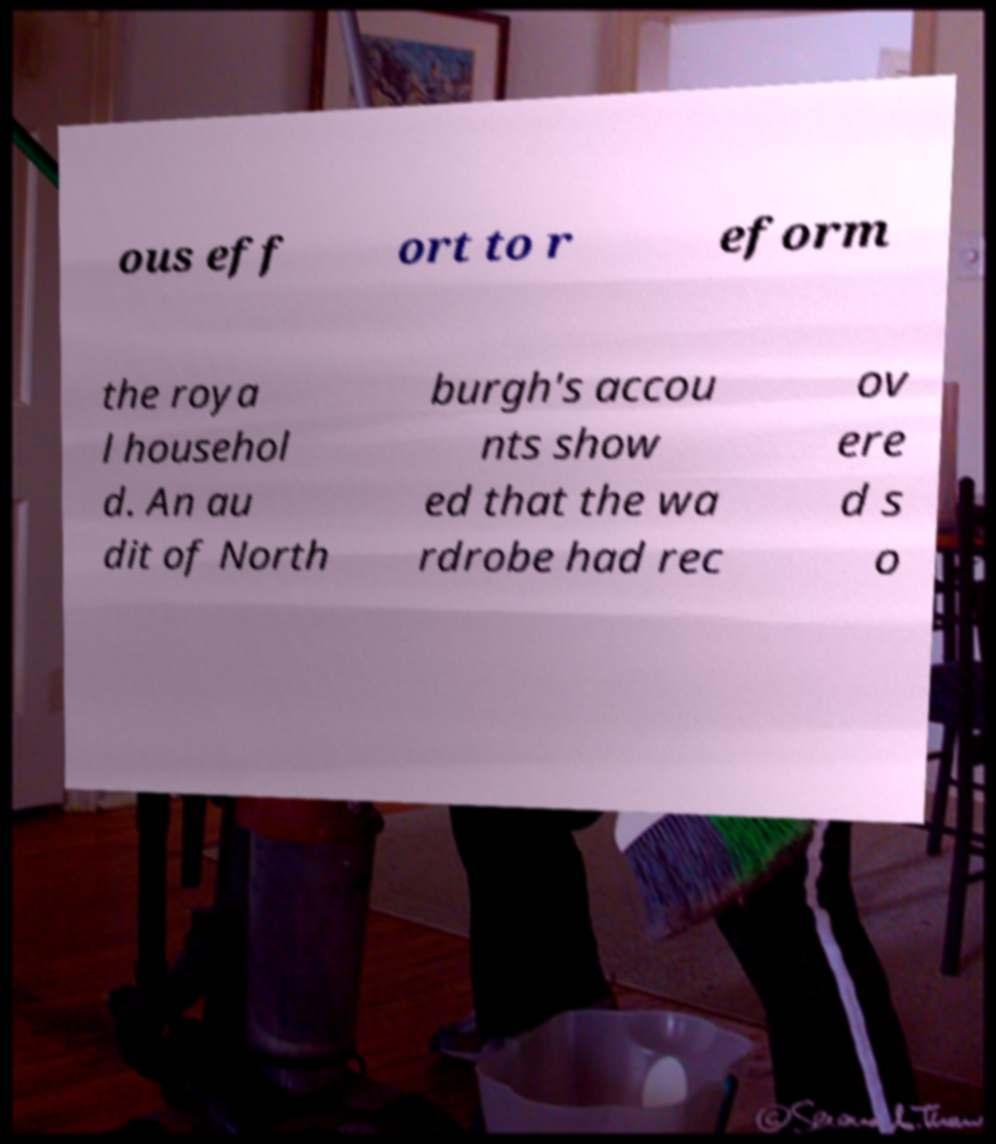Could you assist in decoding the text presented in this image and type it out clearly? ous eff ort to r eform the roya l househol d. An au dit of North burgh's accou nts show ed that the wa rdrobe had rec ov ere d s o 